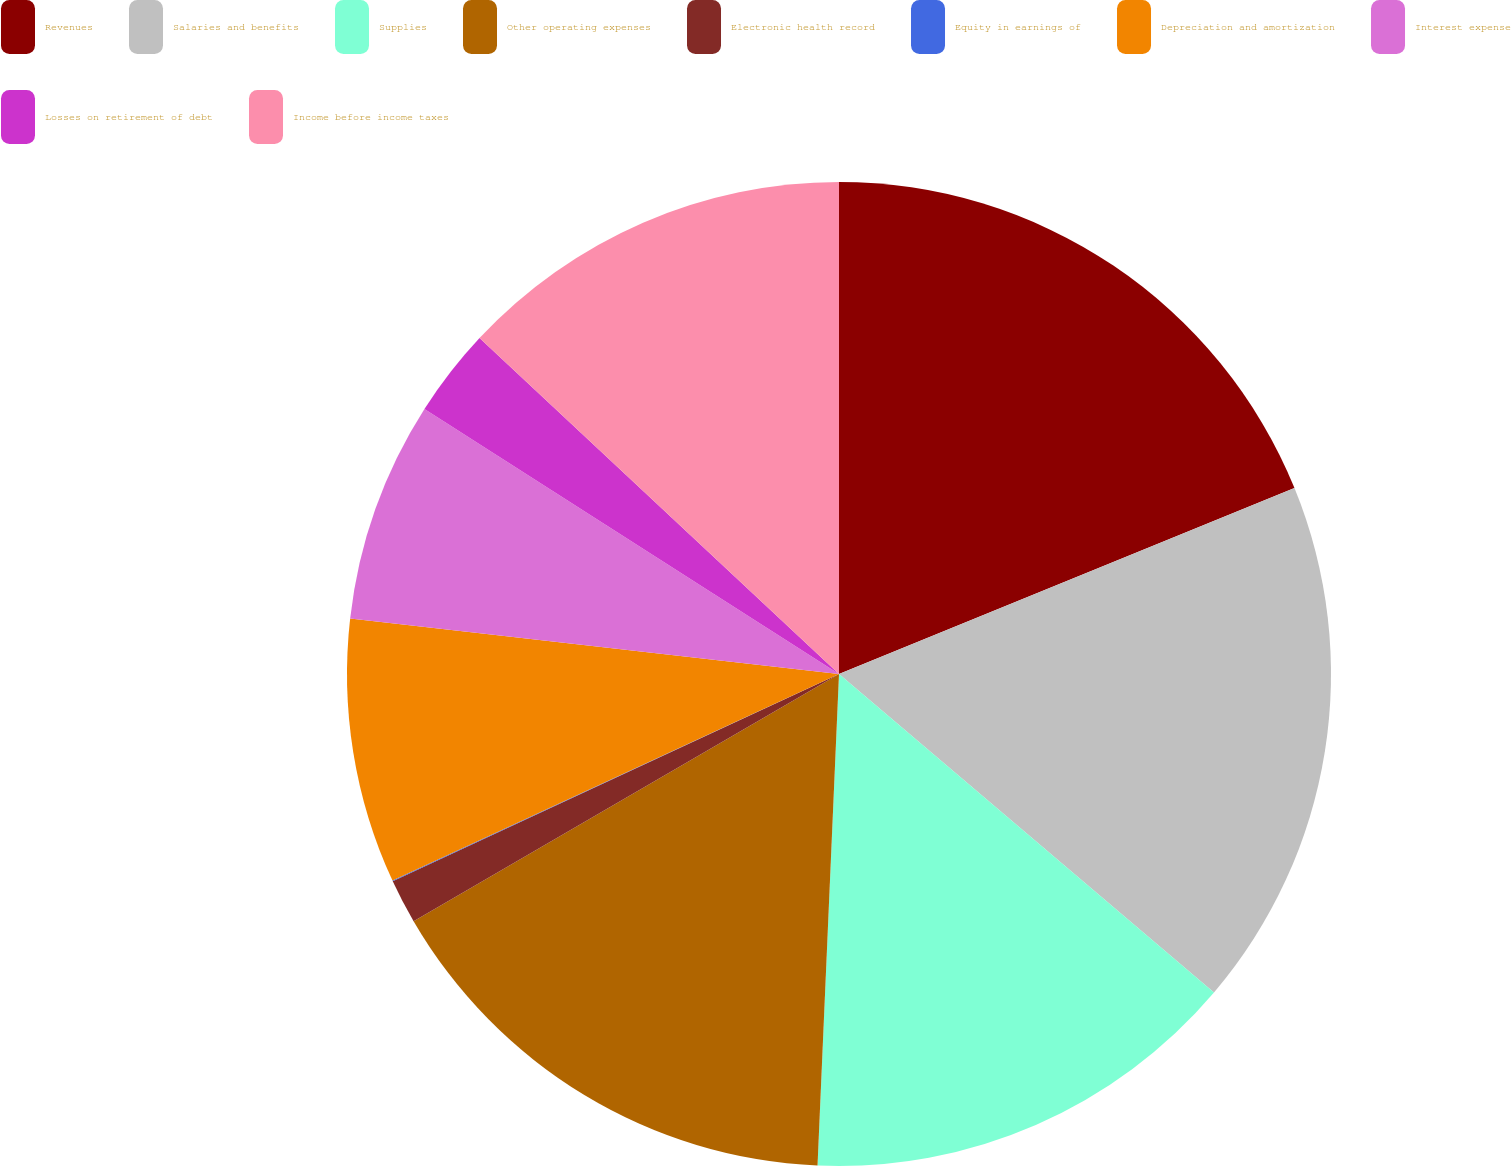Convert chart to OTSL. <chart><loc_0><loc_0><loc_500><loc_500><pie_chart><fcel>Revenues<fcel>Salaries and benefits<fcel>Supplies<fcel>Other operating expenses<fcel>Electronic health record<fcel>Equity in earnings of<fcel>Depreciation and amortization<fcel>Interest expense<fcel>Losses on retirement of debt<fcel>Income before income taxes<nl><fcel>18.83%<fcel>17.38%<fcel>14.49%<fcel>15.93%<fcel>1.46%<fcel>0.02%<fcel>8.7%<fcel>7.25%<fcel>2.91%<fcel>13.04%<nl></chart> 